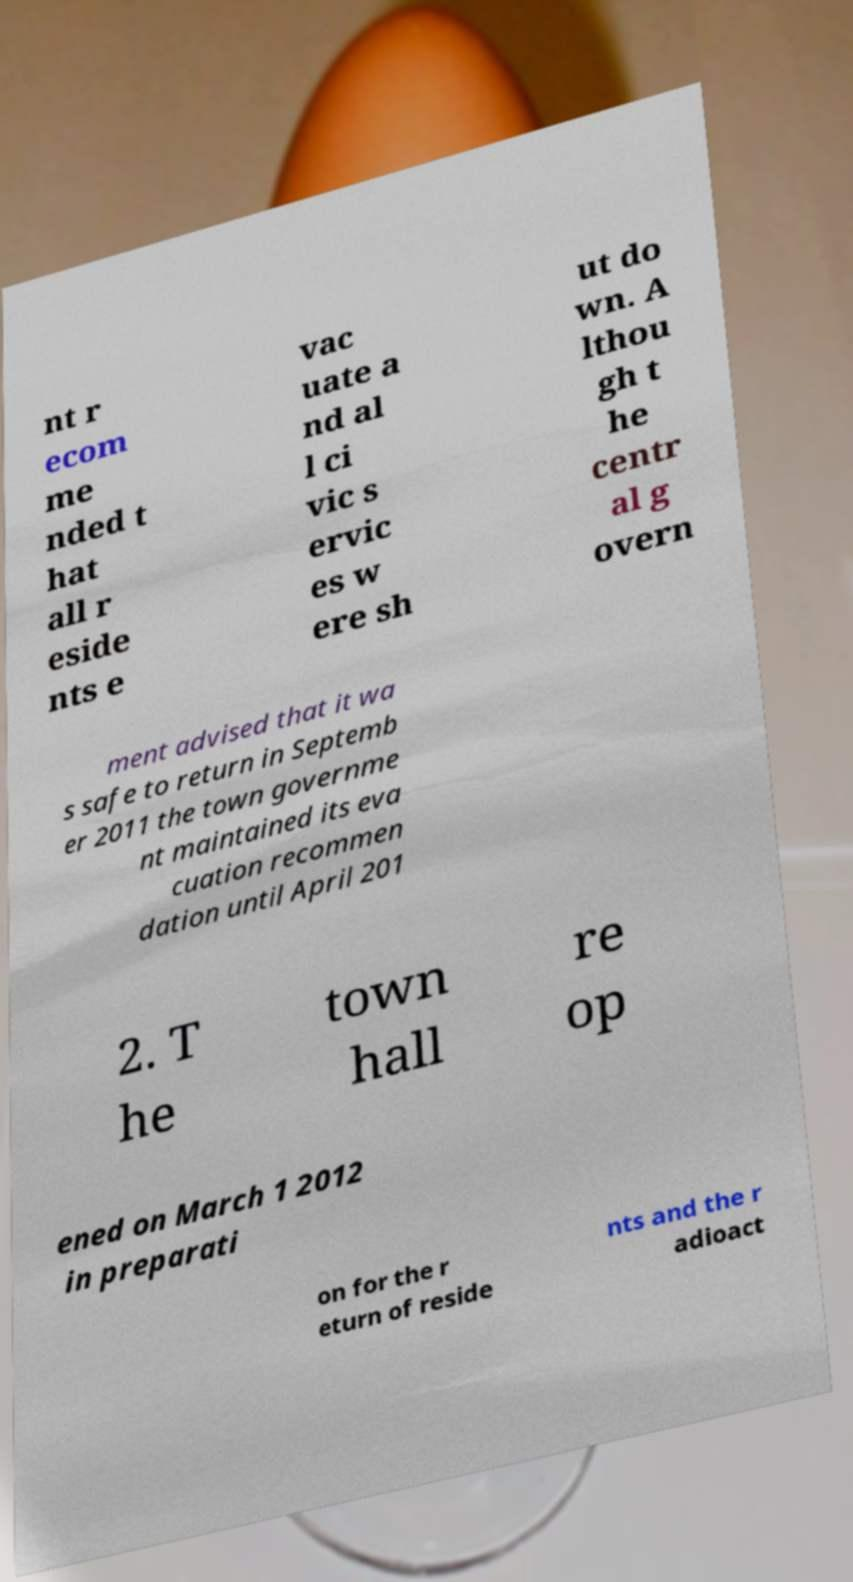There's text embedded in this image that I need extracted. Can you transcribe it verbatim? nt r ecom me nded t hat all r eside nts e vac uate a nd al l ci vic s ervic es w ere sh ut do wn. A lthou gh t he centr al g overn ment advised that it wa s safe to return in Septemb er 2011 the town governme nt maintained its eva cuation recommen dation until April 201 2. T he town hall re op ened on March 1 2012 in preparati on for the r eturn of reside nts and the r adioact 